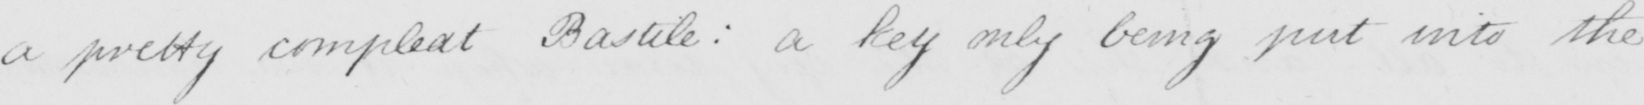What is written in this line of handwriting? a pretty compleat Bastile :  a key only being put into the 